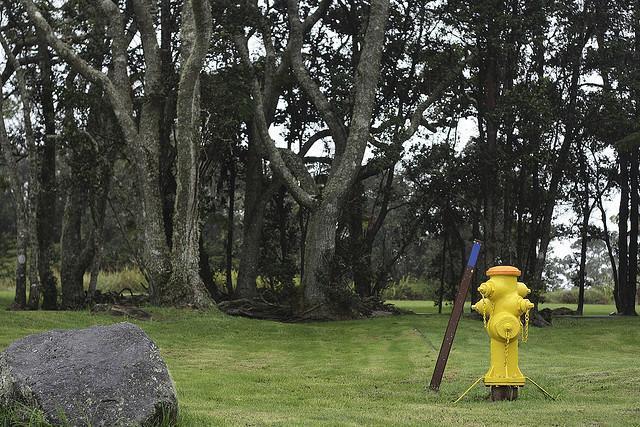How many fire hydrants are there?
Give a very brief answer. 1. 